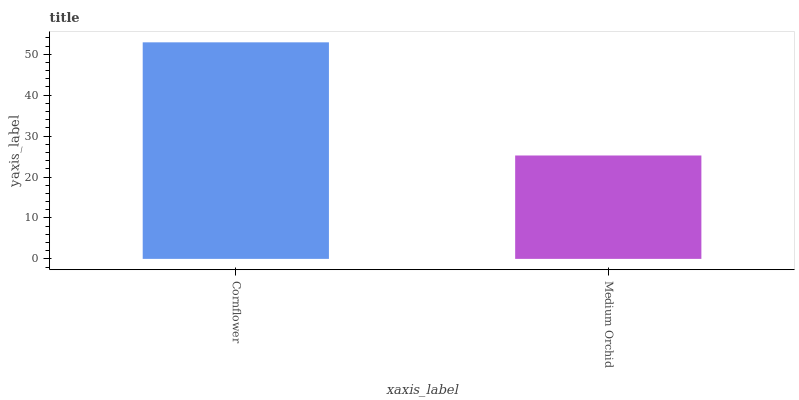Is Medium Orchid the minimum?
Answer yes or no. Yes. Is Cornflower the maximum?
Answer yes or no. Yes. Is Medium Orchid the maximum?
Answer yes or no. No. Is Cornflower greater than Medium Orchid?
Answer yes or no. Yes. Is Medium Orchid less than Cornflower?
Answer yes or no. Yes. Is Medium Orchid greater than Cornflower?
Answer yes or no. No. Is Cornflower less than Medium Orchid?
Answer yes or no. No. Is Cornflower the high median?
Answer yes or no. Yes. Is Medium Orchid the low median?
Answer yes or no. Yes. Is Medium Orchid the high median?
Answer yes or no. No. Is Cornflower the low median?
Answer yes or no. No. 